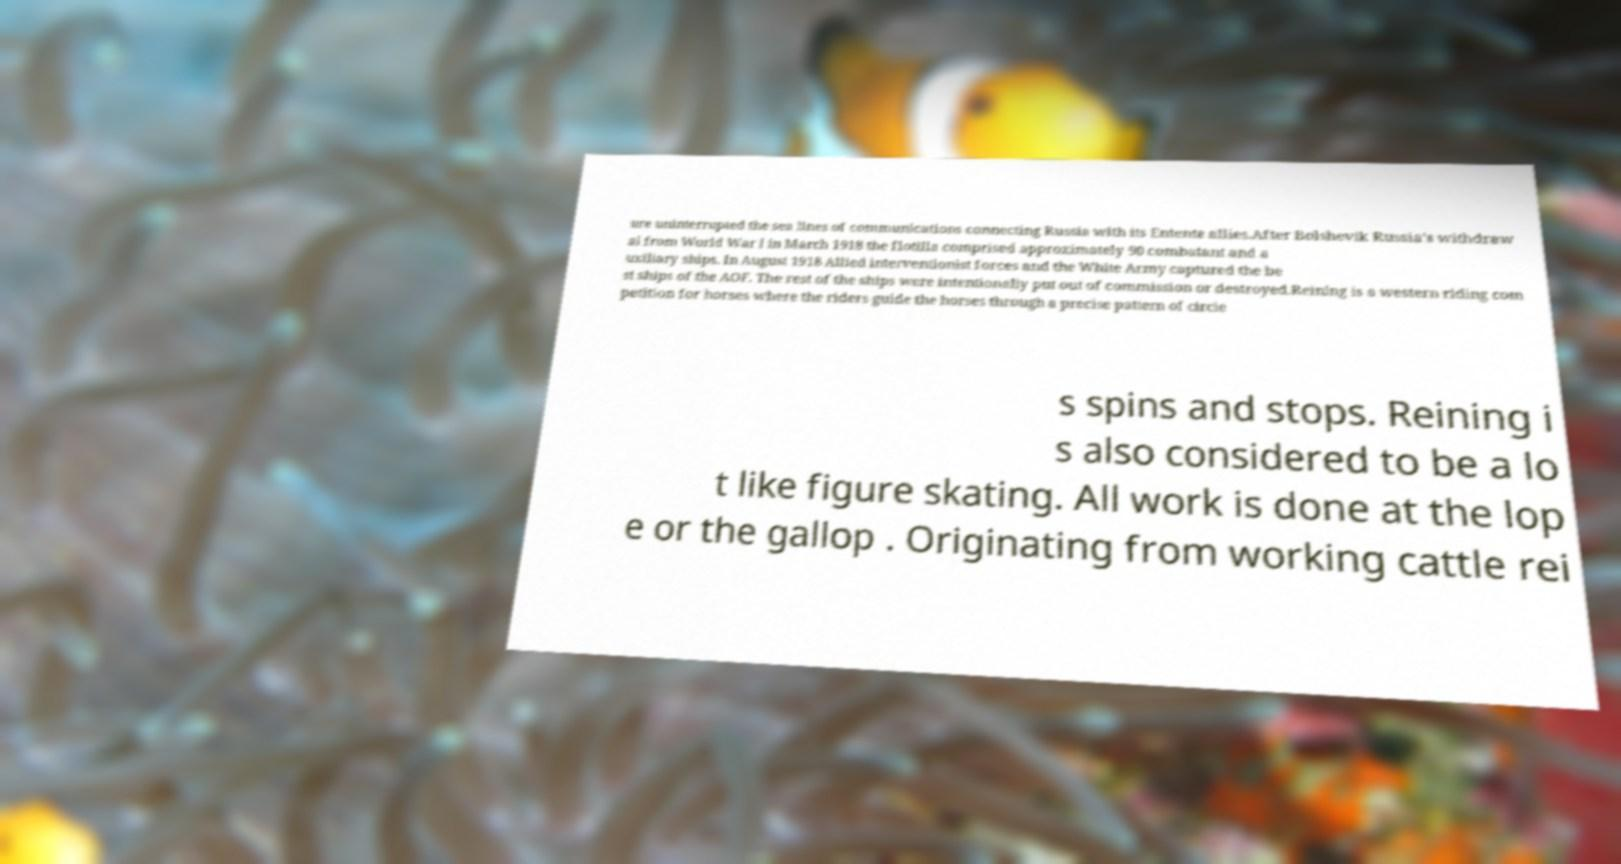For documentation purposes, I need the text within this image transcribed. Could you provide that? ure uninterrupted the sea lines of communications connecting Russia with its Entente allies.After Bolshevik Russia's withdraw al from World War I in March 1918 the flotilla comprised approximately 90 combatant and a uxiliary ships. In August 1918 Allied interventionist forces and the White Army captured the be st ships of the AOF. The rest of the ships were intentionally put out of commission or destroyed.Reining is a western riding com petition for horses where the riders guide the horses through a precise pattern of circle s spins and stops. Reining i s also considered to be a lo t like figure skating. All work is done at the lop e or the gallop . Originating from working cattle rei 